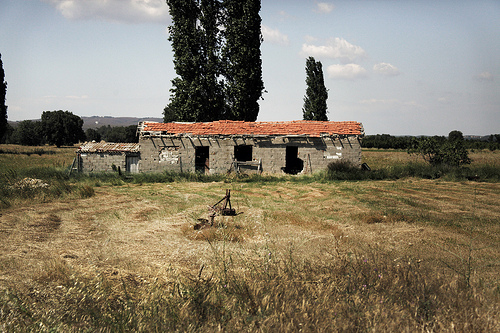<image>
Is there a back building behind the tree? No. The back building is not behind the tree. From this viewpoint, the back building appears to be positioned elsewhere in the scene. 